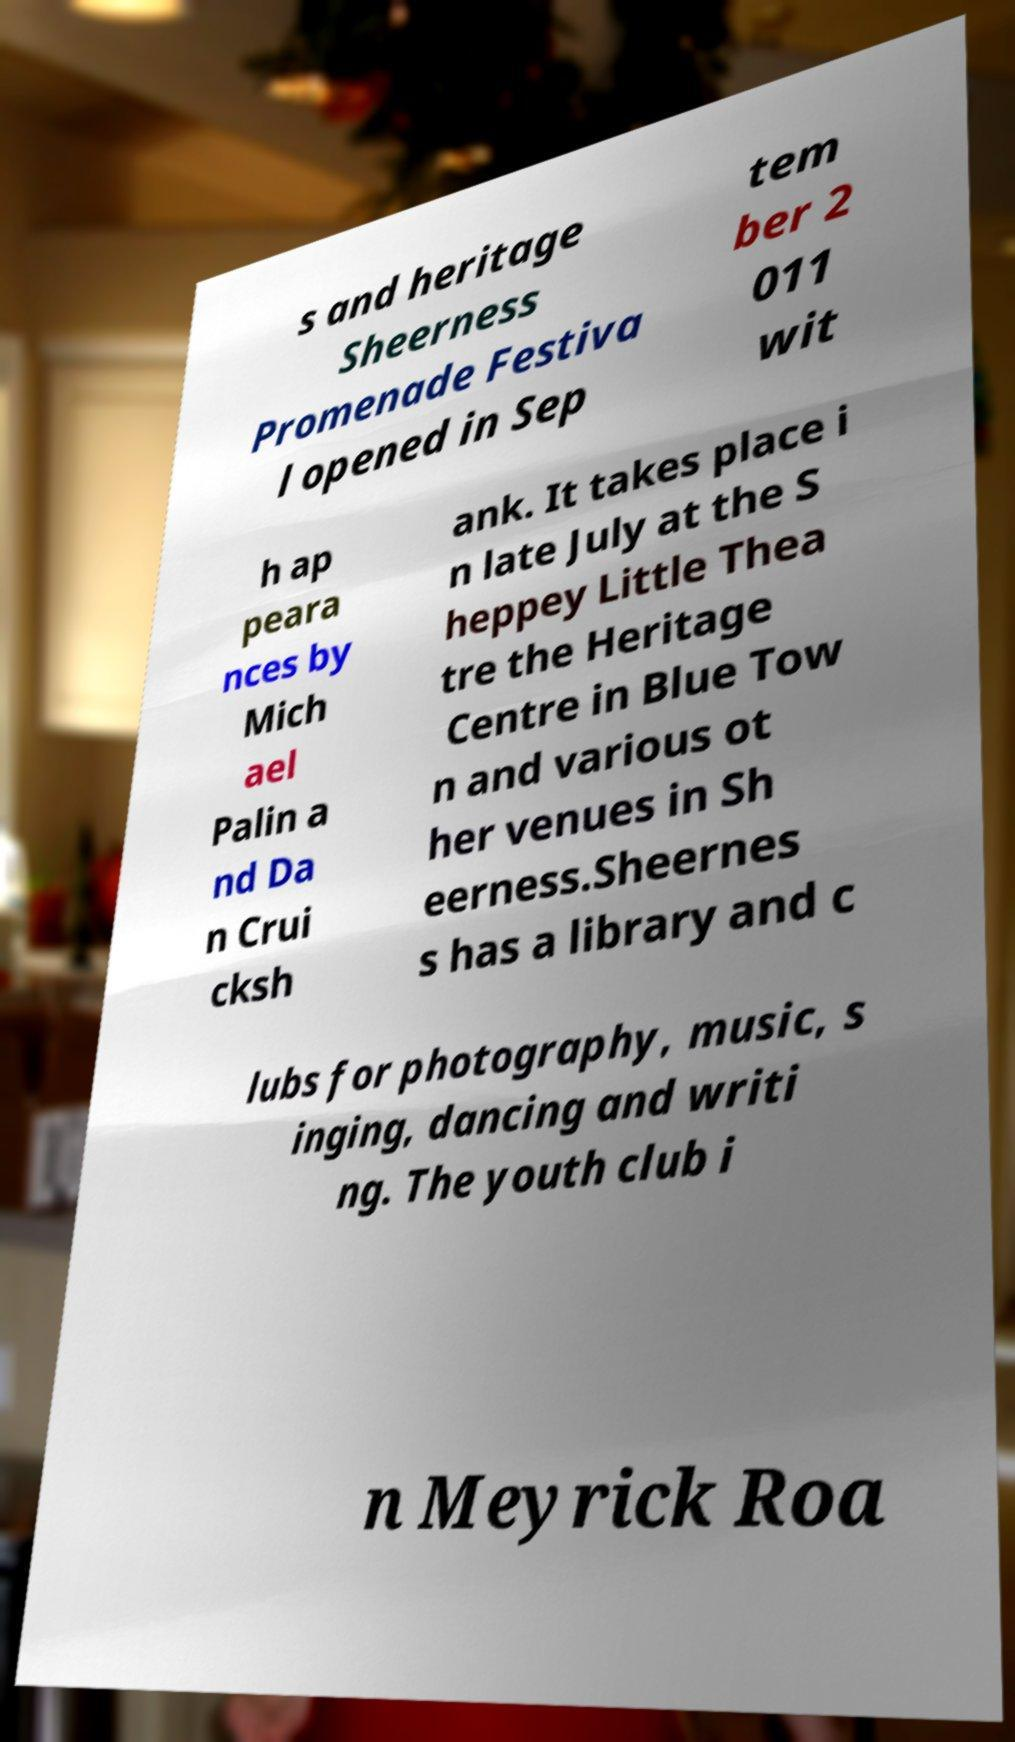Could you extract and type out the text from this image? s and heritage Sheerness Promenade Festiva l opened in Sep tem ber 2 011 wit h ap peara nces by Mich ael Palin a nd Da n Crui cksh ank. It takes place i n late July at the S heppey Little Thea tre the Heritage Centre in Blue Tow n and various ot her venues in Sh eerness.Sheernes s has a library and c lubs for photography, music, s inging, dancing and writi ng. The youth club i n Meyrick Roa 